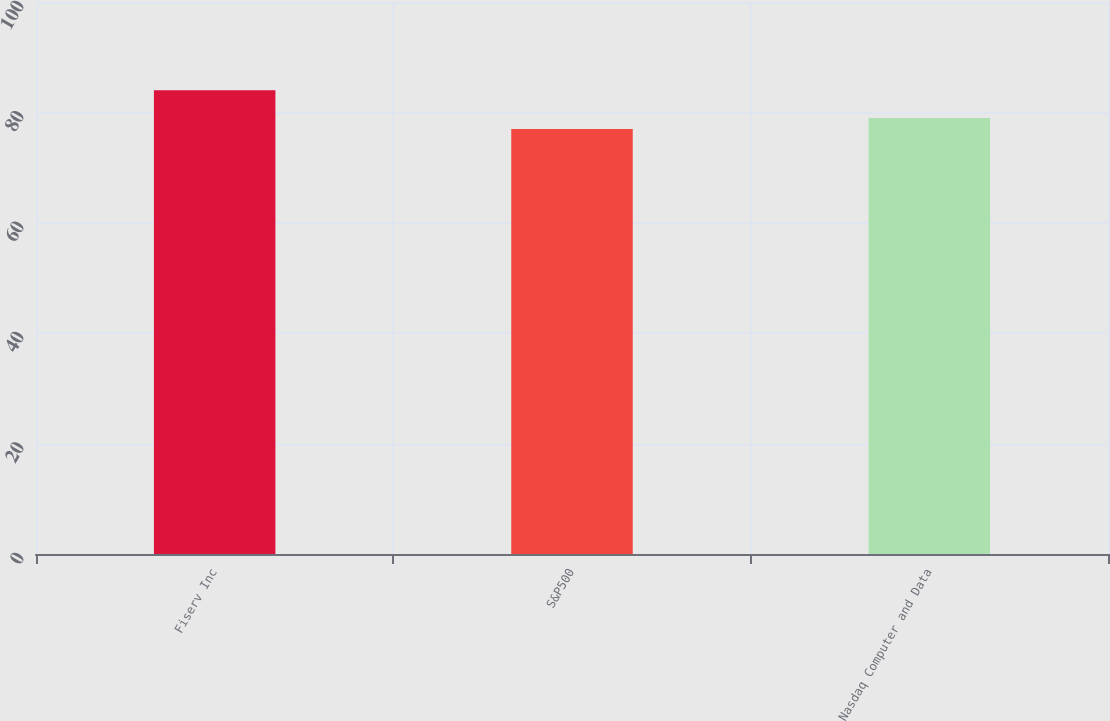Convert chart. <chart><loc_0><loc_0><loc_500><loc_500><bar_chart><fcel>Fiserv Inc<fcel>S&P500<fcel>Nasdaq Computer and Data<nl><fcel>84<fcel>77<fcel>79<nl></chart> 